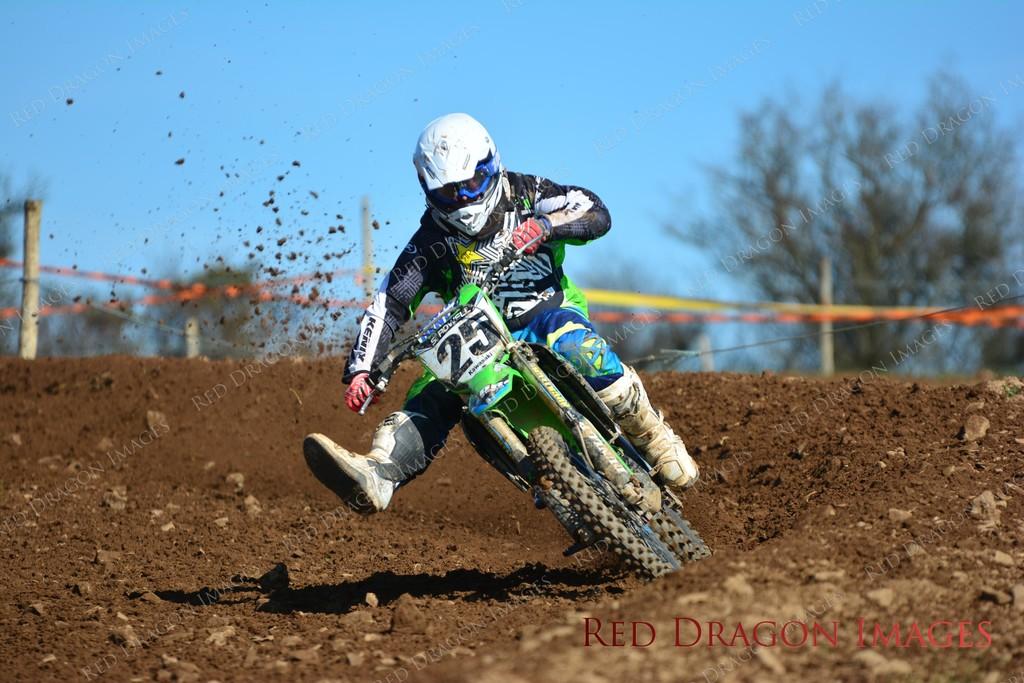What number is the rider?
Provide a succinct answer. 25. 